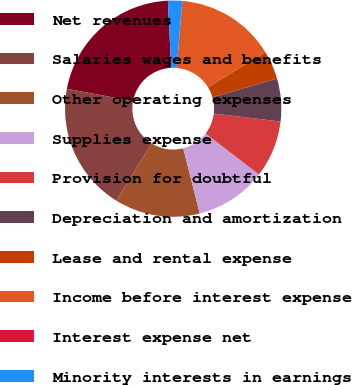Convert chart. <chart><loc_0><loc_0><loc_500><loc_500><pie_chart><fcel>Net revenues<fcel>Salaries wages and benefits<fcel>Other operating expenses<fcel>Supplies expense<fcel>Provision for doubtful<fcel>Depreciation and amortization<fcel>Lease and rental expense<fcel>Income before interest expense<fcel>Interest expense net<fcel>Minority interests in earnings<nl><fcel>21.27%<fcel>19.14%<fcel>12.76%<fcel>10.64%<fcel>8.51%<fcel>6.39%<fcel>4.26%<fcel>14.89%<fcel>0.01%<fcel>2.13%<nl></chart> 